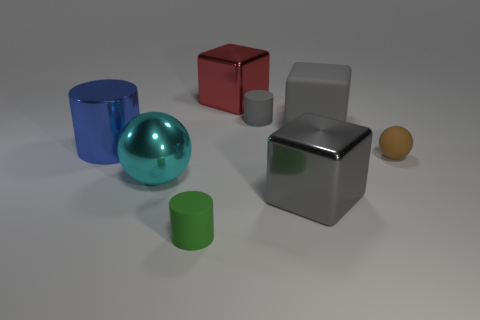Add 2 tiny yellow matte blocks. How many objects exist? 10 Subtract all shiny blocks. How many blocks are left? 1 Subtract all cylinders. How many objects are left? 5 Add 1 big red metal things. How many big red metal things exist? 2 Subtract 0 yellow balls. How many objects are left? 8 Subtract all metallic cubes. Subtract all blue cylinders. How many objects are left? 5 Add 6 blue metallic cylinders. How many blue metallic cylinders are left? 7 